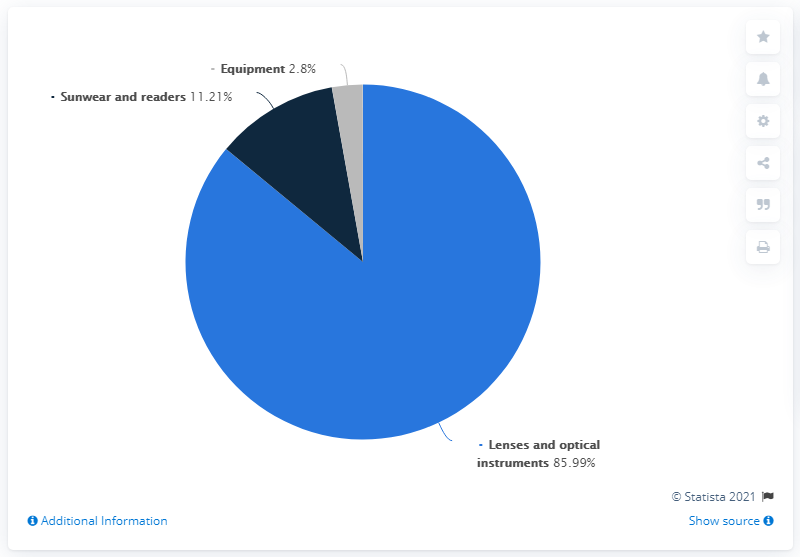Specify some key components in this picture. Essilor generates the highest revenue share from the lenses and optical instruments sector. The difference in revenue share between the highest revenue-generating sector and the lowest revenue-generating sector is 83.19%. In 2019, the global revenue of Essilor's lenses and optical instruments sector was 85.99%. 